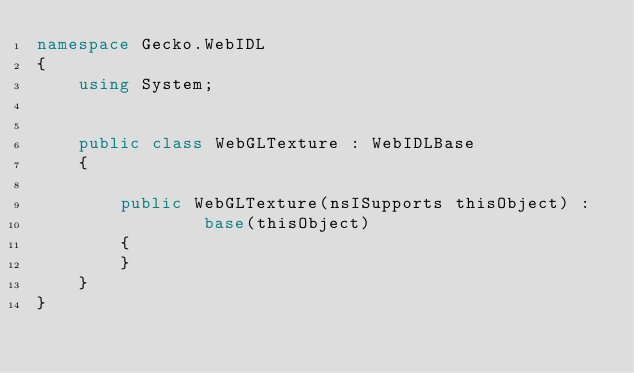<code> <loc_0><loc_0><loc_500><loc_500><_C#_>namespace Gecko.WebIDL
{
    using System;
    
    
    public class WebGLTexture : WebIDLBase
    {
        
        public WebGLTexture(nsISupports thisObject) : 
                base(thisObject)
        {
        }
    }
}
</code> 